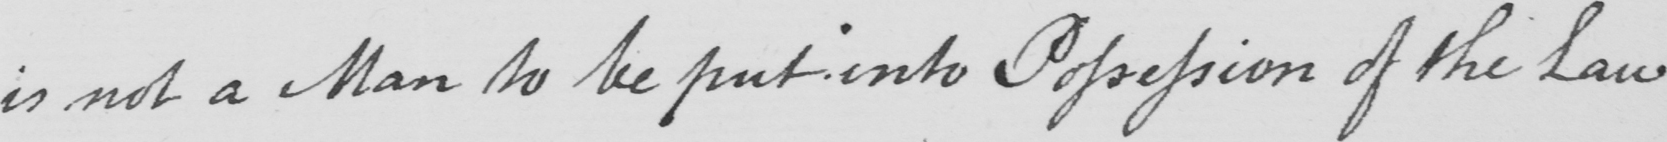Transcribe the text shown in this historical manuscript line. is not a Man to be put into Possession of the Law 